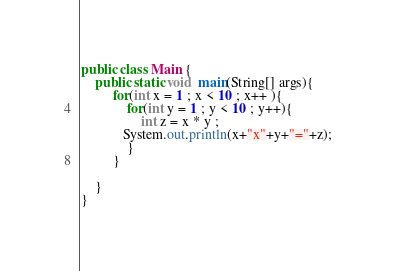<code> <loc_0><loc_0><loc_500><loc_500><_Java_>public class Main {
	public static void  main(String[] args){
		 for(int x = 1 ; x < 10 ; x++ ){
			 for(int y = 1 ; y < 10 ; y++){
				 int z = x * y ;
			System.out.println(x+"x"+y+"="+z);
			 }
		 }
		
	}
}</code> 